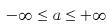Convert formula to latex. <formula><loc_0><loc_0><loc_500><loc_500>- \infty \leq a \leq + \infty</formula> 